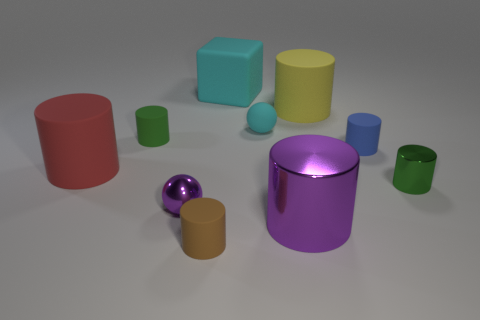Subtract all blue cylinders. How many cylinders are left? 6 Subtract all small green cylinders. How many cylinders are left? 5 Subtract 2 cylinders. How many cylinders are left? 5 Subtract all red blocks. How many gray cylinders are left? 0 Subtract all yellow metallic objects. Subtract all cyan things. How many objects are left? 8 Add 5 green metallic cylinders. How many green metallic cylinders are left? 6 Add 6 cyan rubber balls. How many cyan rubber balls exist? 7 Subtract 0 red blocks. How many objects are left? 10 Subtract all balls. How many objects are left? 8 Subtract all purple spheres. Subtract all blue cylinders. How many spheres are left? 1 